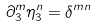Convert formula to latex. <formula><loc_0><loc_0><loc_500><loc_500>\partial ^ { m } _ { 3 } \eta ^ { n } _ { 3 } = \delta ^ { m n }</formula> 